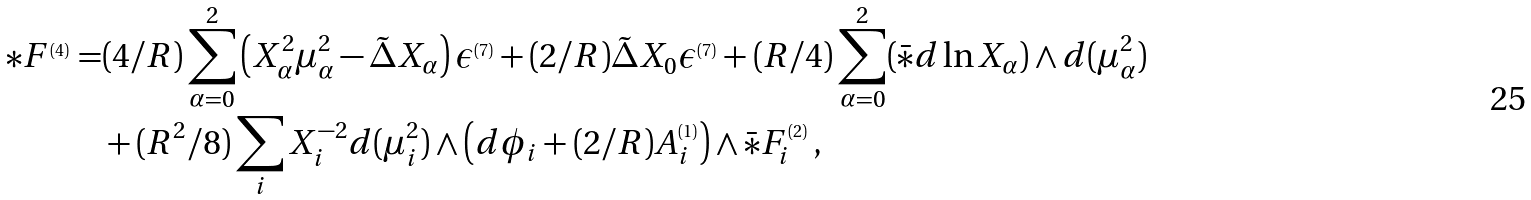Convert formula to latex. <formula><loc_0><loc_0><loc_500><loc_500>* F ^ { _ { ( 4 ) } } = & ( 4 / R ) \sum _ { \alpha = 0 } ^ { 2 } \left ( X _ { \alpha } ^ { 2 } \mu _ { \alpha } ^ { 2 } - \tilde { \Delta } X _ { \alpha } \right ) \epsilon ^ { _ { ( 7 ) } } + ( 2 / R ) \tilde { \Delta } X _ { 0 } \epsilon ^ { _ { ( 7 ) } } + ( R / 4 ) \sum _ { \alpha = 0 } ^ { 2 } ( \bar { * } d \ln X _ { \alpha } ) \wedge d ( \mu _ { \alpha } ^ { 2 } ) \\ & + ( R ^ { 2 } / 8 ) \sum _ { i } X _ { i } ^ { - 2 } d ( \mu _ { i } ^ { 2 } ) \wedge \left ( d \phi _ { i } + ( 2 / R ) A _ { i } ^ { _ { ( 1 ) } } \right ) \wedge \bar { * } F _ { i } ^ { _ { ( 2 ) } } \, ,</formula> 